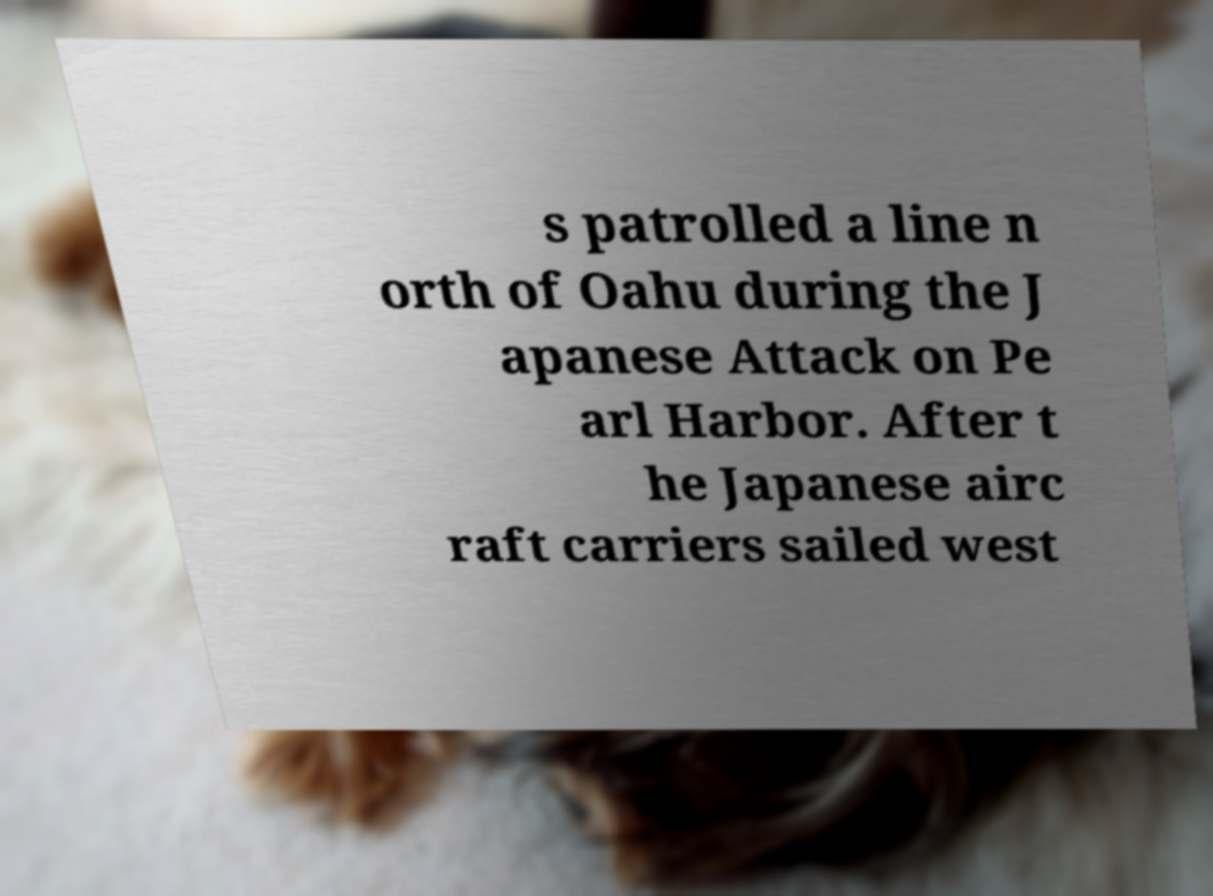Can you read and provide the text displayed in the image?This photo seems to have some interesting text. Can you extract and type it out for me? s patrolled a line n orth of Oahu during the J apanese Attack on Pe arl Harbor. After t he Japanese airc raft carriers sailed west 